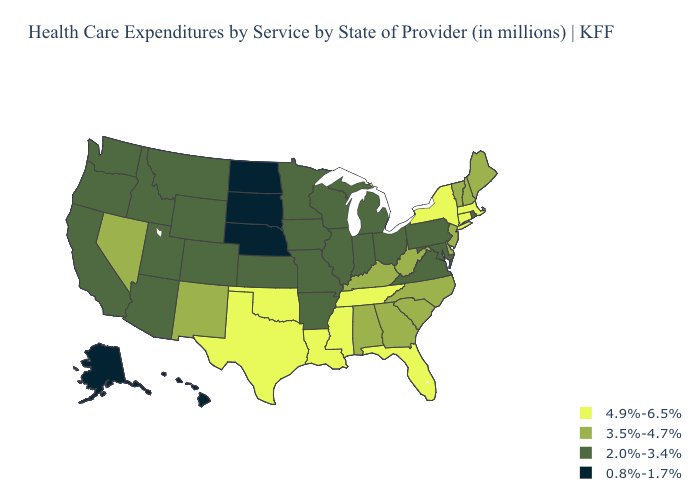Name the states that have a value in the range 4.9%-6.5%?
Write a very short answer. Connecticut, Florida, Louisiana, Massachusetts, Mississippi, New York, Oklahoma, Tennessee, Texas. Name the states that have a value in the range 4.9%-6.5%?
Short answer required. Connecticut, Florida, Louisiana, Massachusetts, Mississippi, New York, Oklahoma, Tennessee, Texas. Name the states that have a value in the range 4.9%-6.5%?
Answer briefly. Connecticut, Florida, Louisiana, Massachusetts, Mississippi, New York, Oklahoma, Tennessee, Texas. Does Nevada have a higher value than Michigan?
Concise answer only. Yes. Does the first symbol in the legend represent the smallest category?
Give a very brief answer. No. Does Indiana have the lowest value in the USA?
Short answer required. No. What is the value of Iowa?
Short answer required. 2.0%-3.4%. What is the value of Pennsylvania?
Write a very short answer. 2.0%-3.4%. Name the states that have a value in the range 4.9%-6.5%?
Quick response, please. Connecticut, Florida, Louisiana, Massachusetts, Mississippi, New York, Oklahoma, Tennessee, Texas. Name the states that have a value in the range 3.5%-4.7%?
Quick response, please. Alabama, Delaware, Georgia, Kentucky, Maine, Nevada, New Hampshire, New Jersey, New Mexico, North Carolina, South Carolina, Vermont, West Virginia. What is the value of North Carolina?
Concise answer only. 3.5%-4.7%. What is the highest value in the West ?
Answer briefly. 3.5%-4.7%. What is the value of Nebraska?
Be succinct. 0.8%-1.7%. What is the lowest value in the MidWest?
Quick response, please. 0.8%-1.7%. Is the legend a continuous bar?
Give a very brief answer. No. 